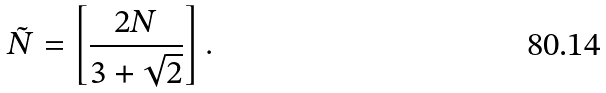Convert formula to latex. <formula><loc_0><loc_0><loc_500><loc_500>\tilde { N } = \left [ \frac { 2 N } { 3 + \sqrt { 2 } } \right ] .</formula> 